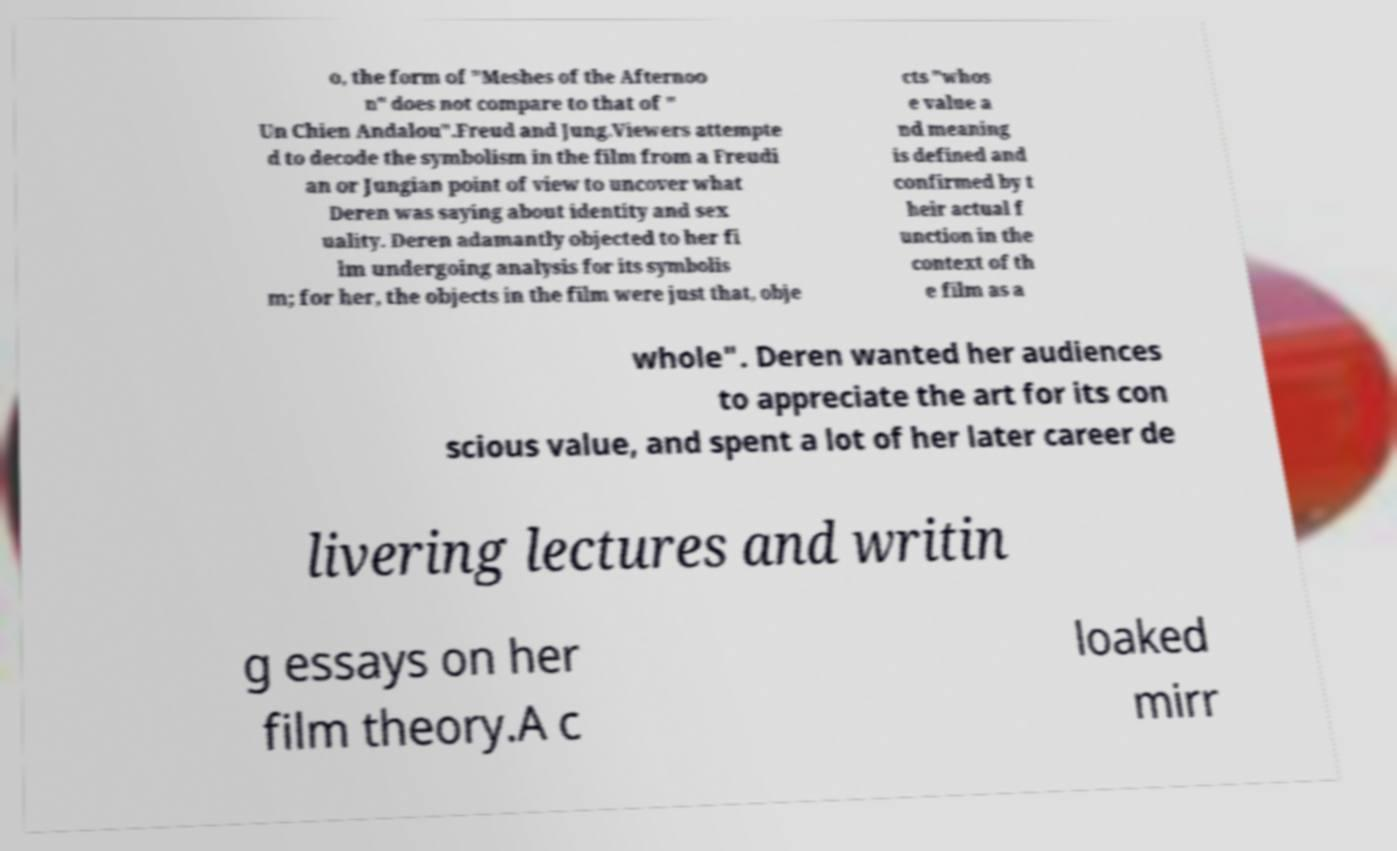Could you assist in decoding the text presented in this image and type it out clearly? o, the form of "Meshes of the Afternoo n" does not compare to that of " Un Chien Andalou".Freud and Jung.Viewers attempte d to decode the symbolism in the film from a Freudi an or Jungian point of view to uncover what Deren was saying about identity and sex uality. Deren adamantly objected to her fi lm undergoing analysis for its symbolis m; for her, the objects in the film were just that, obje cts "whos e value a nd meaning is defined and confirmed by t heir actual f unction in the context of th e film as a whole". Deren wanted her audiences to appreciate the art for its con scious value, and spent a lot of her later career de livering lectures and writin g essays on her film theory.A c loaked mirr 